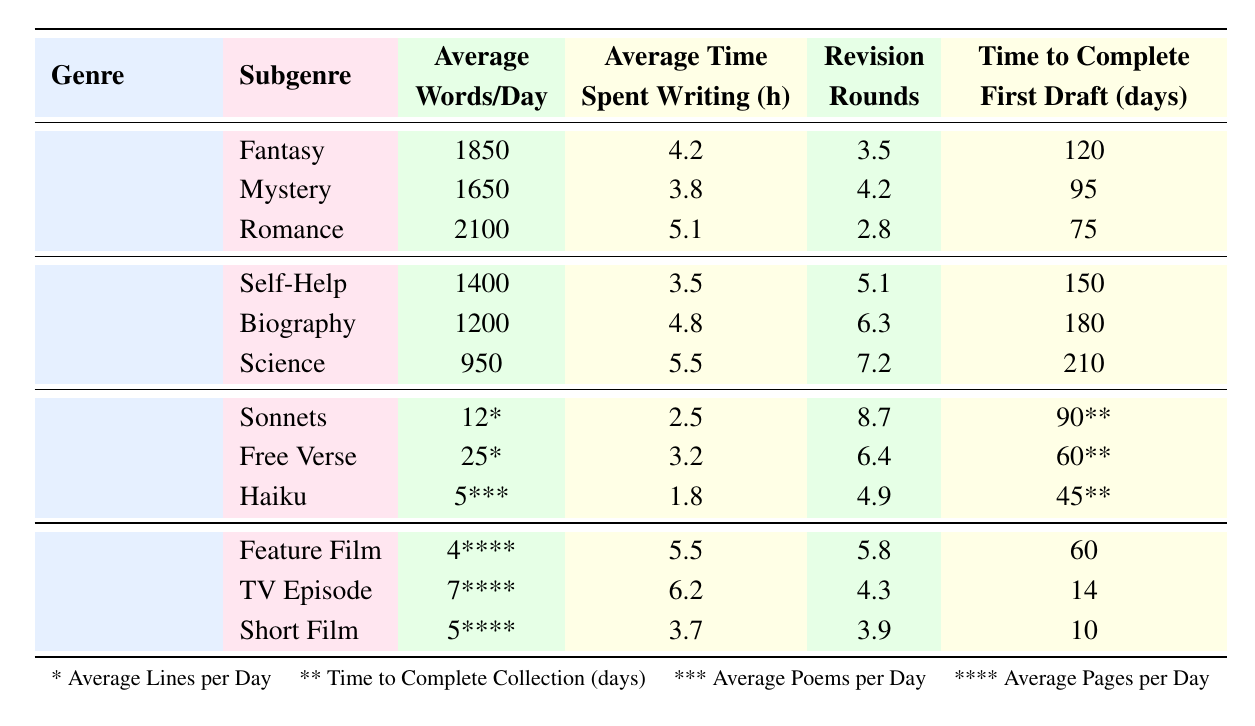What is the average number of words written per day in the Romance subgenre? The table shows that the Average Words per Day for the Romance subgenre is 2100.
Answer: 2100 Which genre has the highest average time spent writing? By comparing the average time spent writing across genres, Non-Fiction has the highest value with an average of 4.8 hours for Biography and 5.5 hours for Science. Thus, the overall highest is in the Science subgenre.
Answer: Science How many revision rounds does the Fantasy subgenre typically go through? The table indicates that the Average Revision Rounds for the Fantasy subgenre is 3.5.
Answer: 3.5 What is the total average words written per day for all subgenres in Fiction? The average words per day for Fiction subgenres are 1850 (Fantasy), 1650 (Mystery), and 2100 (Romance). Summing these gives 1850 + 1650 + 2100 = 5600.
Answer: 5600 Does the Poetry genre require more average revision rounds than the Romance subgenre in Fiction? The Average Revision Rounds for Sonnets in Poetry is 8.7, while for Romance it is 2.8. Since 8.7 is greater than 2.8, the statement is true.
Answer: Yes What is the average time to complete the first draft across all Non-Fiction subgenres? The time to complete first drafts for Non-Fiction subgenres are 150 days (Self-Help), 180 days (Biography), and 210 days (Science). The average is calculated as (150 + 180 + 210) / 3 = 180.
Answer: 180 Which subgenre within Screenwriting takes the shortest time to complete a first draft? Comparing the time to complete first drafts, the Short Film subgenre takes 10 days, which is shorter than 14 days (TV Episode) and 60 days (Feature Film).
Answer: Short Film What is the relationship between average words per day and revision rounds in the Mystery subgenre? In the Mystery subgenre, the Average Words per Day is 1650, while the Revision Rounds average is 4.2. There is no direct relationship established in the table; the values are independent attributes.
Answer: Independent attributes Which subgenre in Non-Fiction has the lowest average words written per day, and how many words is it? The subgenre with the lowest average words per day in Non-Fiction is Science, which has an average of 950 words.
Answer: Science, 950 Is it true that Fiction subgenres generally require fewer revision rounds than Non-Fiction subgenres? The average revision rounds for Fiction (3.5 for Fantasy, 4.2 for Mystery, and 2.8 for Romance) average to (3.5 + 4.2 + 2.8) / 3 = 3.5. For Non-Fiction, it averages (5.1 + 6.3 + 7.2) / 3 = 6.2. Since 3.5 is less than 6.2, this statement is true.
Answer: Yes 